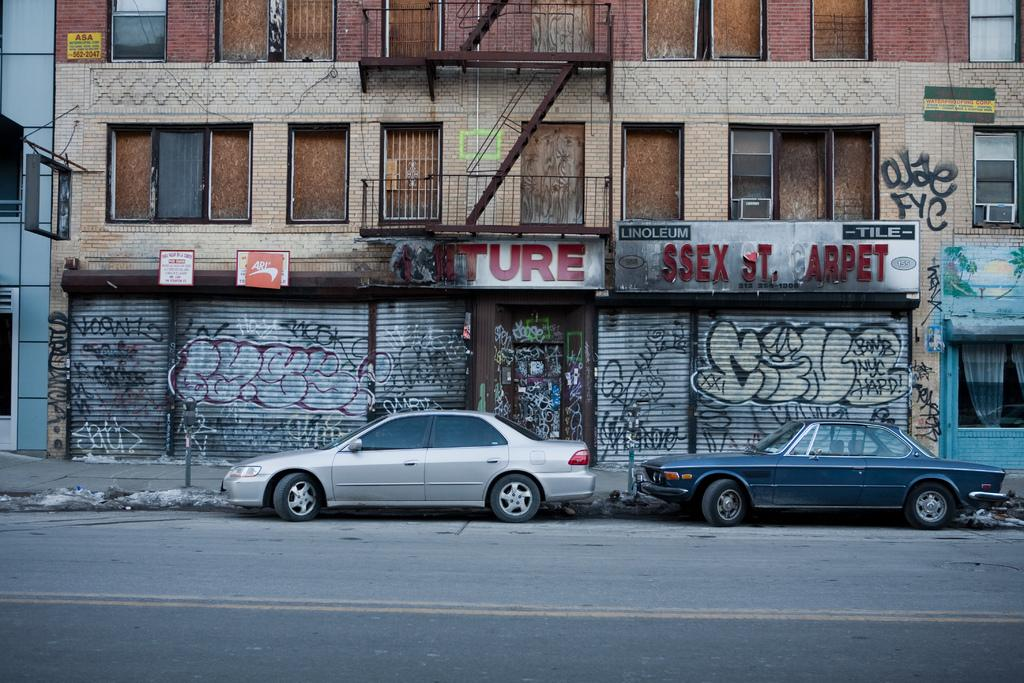What is happening on the road in the image? There are vehicles on the road in the image. What can be seen in the background of the image? There are buildings in the background of the image. What features do the buildings have? The buildings have shutters, boards with writing on them, and windows. What else is visible in the background of the image? There are other objects visible in the background of the image. What type of rice is being cooked in the image? There is no rice present in the image. What kind of apparel is the aunt wearing in the image? There is no aunt or apparel present in the image. 